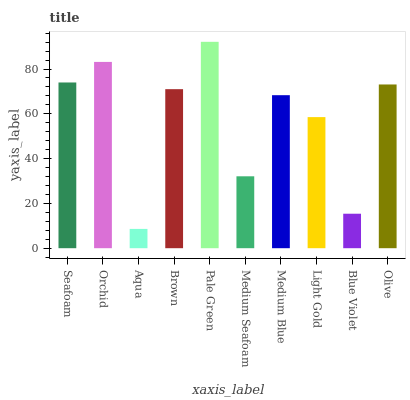Is Aqua the minimum?
Answer yes or no. Yes. Is Pale Green the maximum?
Answer yes or no. Yes. Is Orchid the minimum?
Answer yes or no. No. Is Orchid the maximum?
Answer yes or no. No. Is Orchid greater than Seafoam?
Answer yes or no. Yes. Is Seafoam less than Orchid?
Answer yes or no. Yes. Is Seafoam greater than Orchid?
Answer yes or no. No. Is Orchid less than Seafoam?
Answer yes or no. No. Is Brown the high median?
Answer yes or no. Yes. Is Medium Blue the low median?
Answer yes or no. Yes. Is Medium Blue the high median?
Answer yes or no. No. Is Brown the low median?
Answer yes or no. No. 